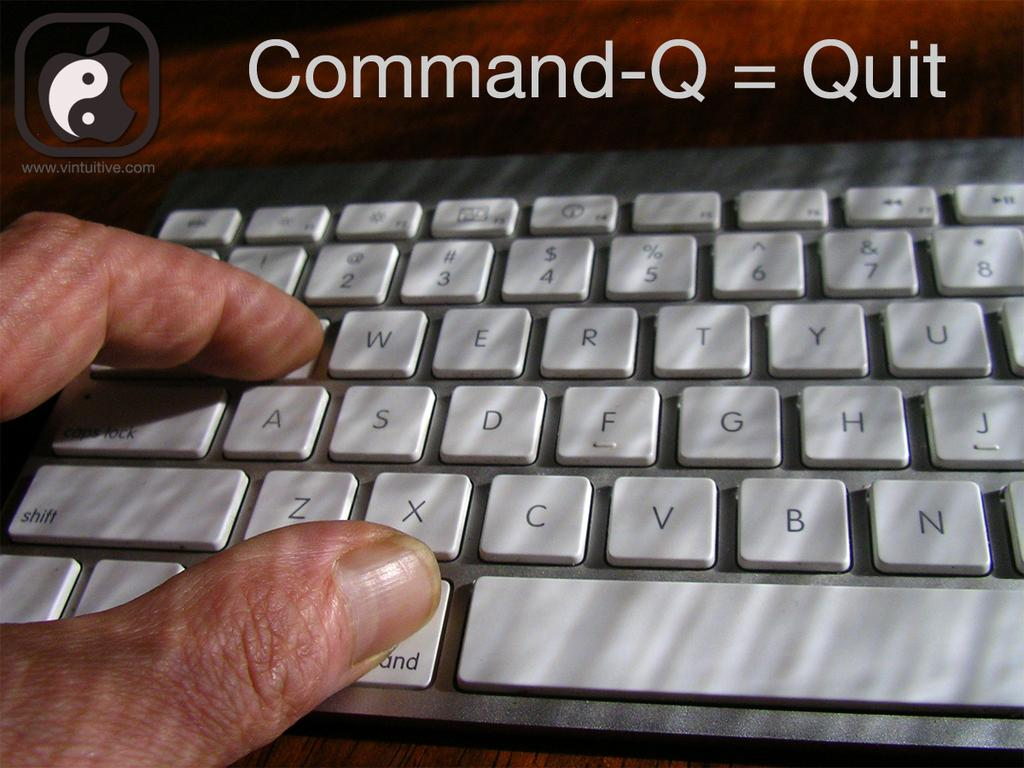<image>
Share a concise interpretation of the image provided. Fingers are on the command and Q keys per the instructions to use that to quit. 